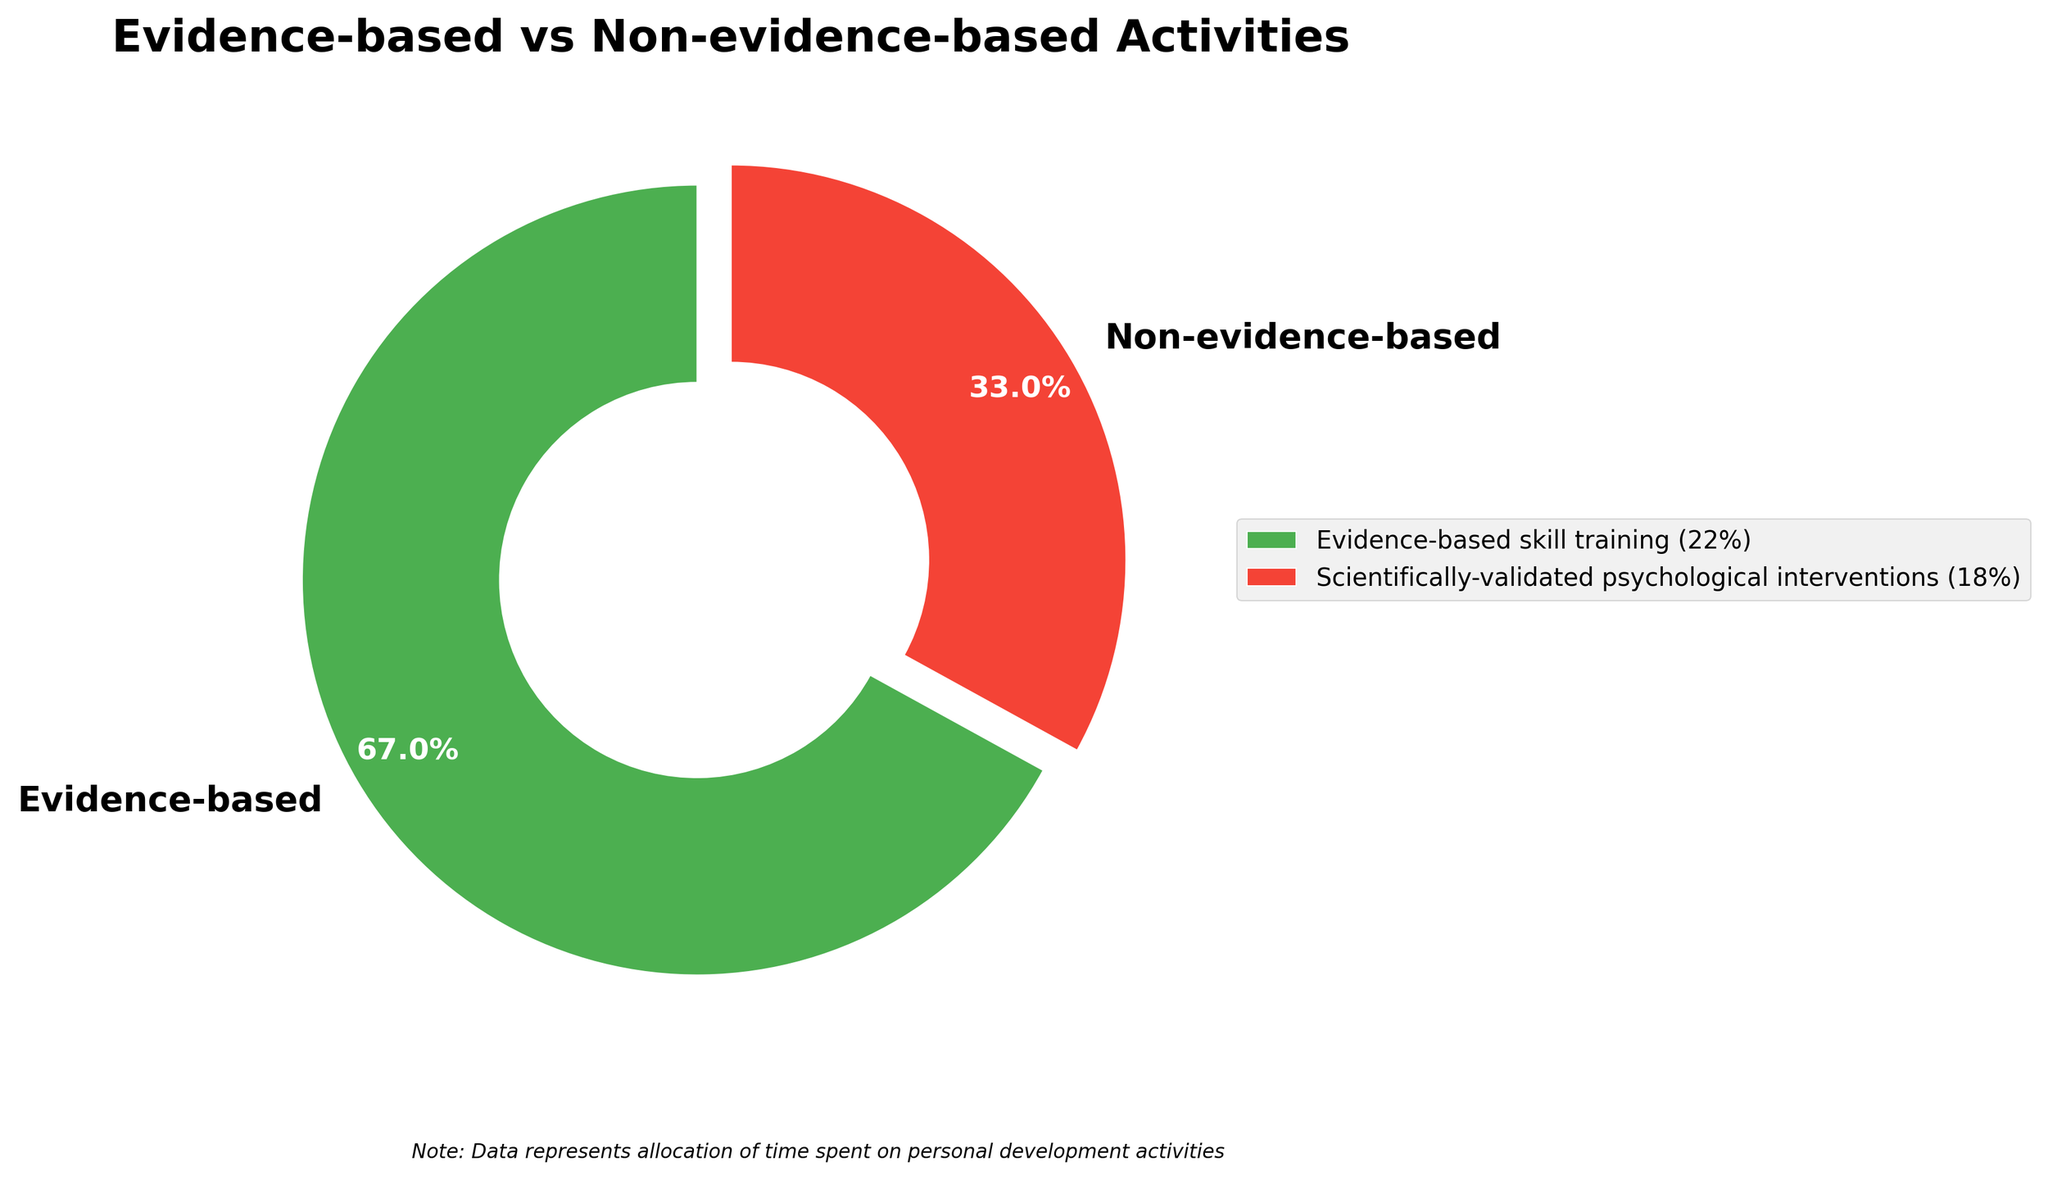What percentage of time is spent on evidence-based activities? The figure labels two categories: 'Evidence-based' and 'Non-evidence-based.' It shows the percentage for 'Evidence-based.'
Answer: 67% What is the combined percentage of time spent on non-evidence-based life coaching and unproven self-help seminars? Identify the percentages for both 'Non-evidence-based life coaching' (9%) and 'Unproven self-help seminars' (8%) from the legend, then sum them up.
Answer: 17% Which category has a higher percentage of time allocation: evidence-based skill training or structured goal-setting and tracking? From the legend, compare 'Evidence-based skill training' (22%) with 'Structured goal-setting and tracking' (15%).
Answer: Evidence-based skill training What activity has the lowest percentage allocation? From the legend, identify the activity with the smallest percentage.
Answer: New Age spiritual practices How many additional percentage points are dedicated to scientifically-validated psychological interventions compared to pseudoscientific personal development programs? Identify the percentages for 'Scientifically-validated psychological interventions' (18%) and 'Pseudoscientific personal development programs' (7%), then subtract the latter from the former.
Answer: 11% What is the difference in percentages between evidence-based and non-evidence-based activities? From the pie chart, evidence-based is 67% and non-evidence-based is 33%. Subtract the non-evidence-based percentage from the evidence-based one.
Answer: 34% What color represents evidence-based activities in the pie chart? Refer to the color of the 'Evidence-based' slice in the pie chart.
Answer: Green Which activity group occupies the majority of the pie chart? From the visual inspection of the pie chart, identify which labeled section is the largest.
Answer: Evidence-based What percentage of time is allocated to activities under non-evidence-based but excluding motivational speaking events and New Age spiritual practices? Sum up the percentages of the non-evidence-based activities excluding 'Motivational speaking events' (5%) and 'New Age spiritual practices' (4%), which are 'Non-evidence-based life coaching' (9%), 'Unproven self-help seminars' (8%), and 'Pseudoscientific personal development programs' (7%).
Answer: 24% 